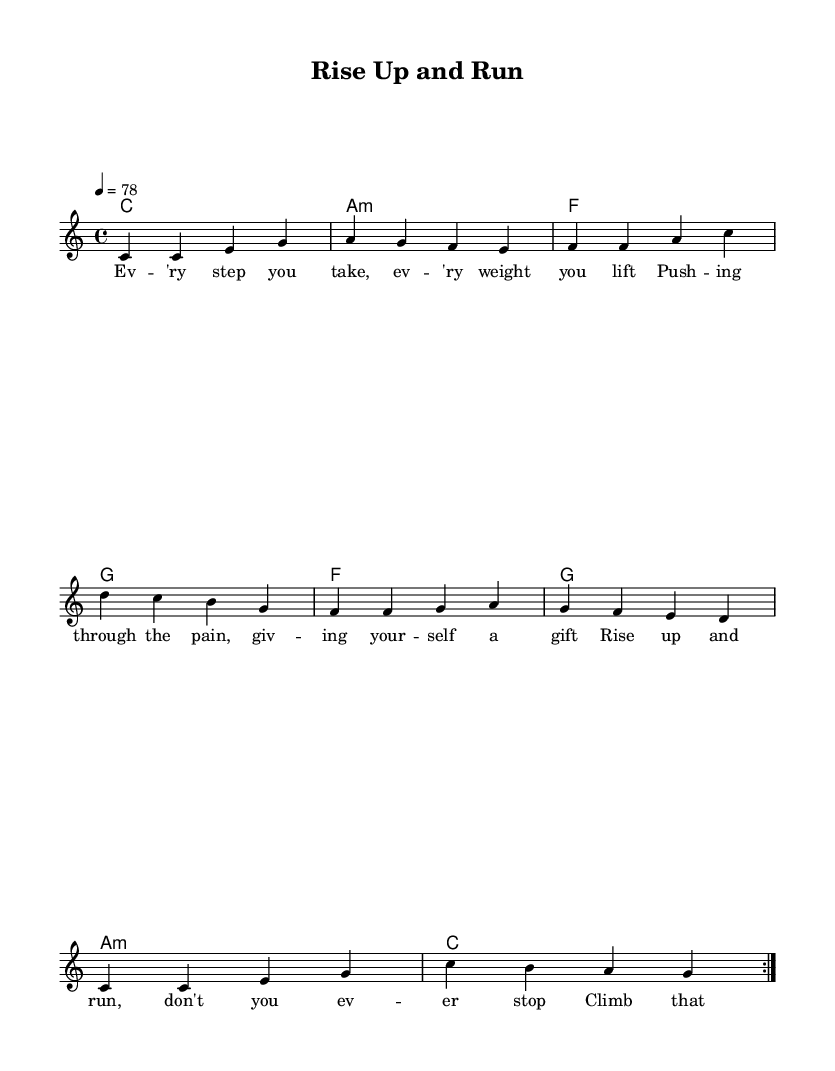What is the key signature of this music? The key signature is indicated at the beginning of the music, showing that there are no sharps or flats. This corresponds to C major.
Answer: C major What is the time signature of this music? The time signature, found at the beginning, is 4/4, meaning there are four beats in each measure.
Answer: 4/4 What tempo marking is used in this piece? The tempo marking indicates the speed of the piece, which is set to a quarter note = 78 beats per minute.
Answer: 78 How many times is the main melody repeated? The melody section includes a repeat sign, indicating that it is played two times.
Answer: 2 What is the tempo marking used in reggae music more commonly? Reggae often features laid-back tempos; however, this specific piece has a moderate tempo marking of 78 BPM.
Answer: Moderate In which part of the lyrics is the phrase "Rise up and run" found? The phrase appears in the first verse, providing motivation and a call to action in the context of fitness.
Answer: First verse What chord follows the A minor chord in the harmonies? The chord progression shows that the chord following the A minor chord is F major.
Answer: F 